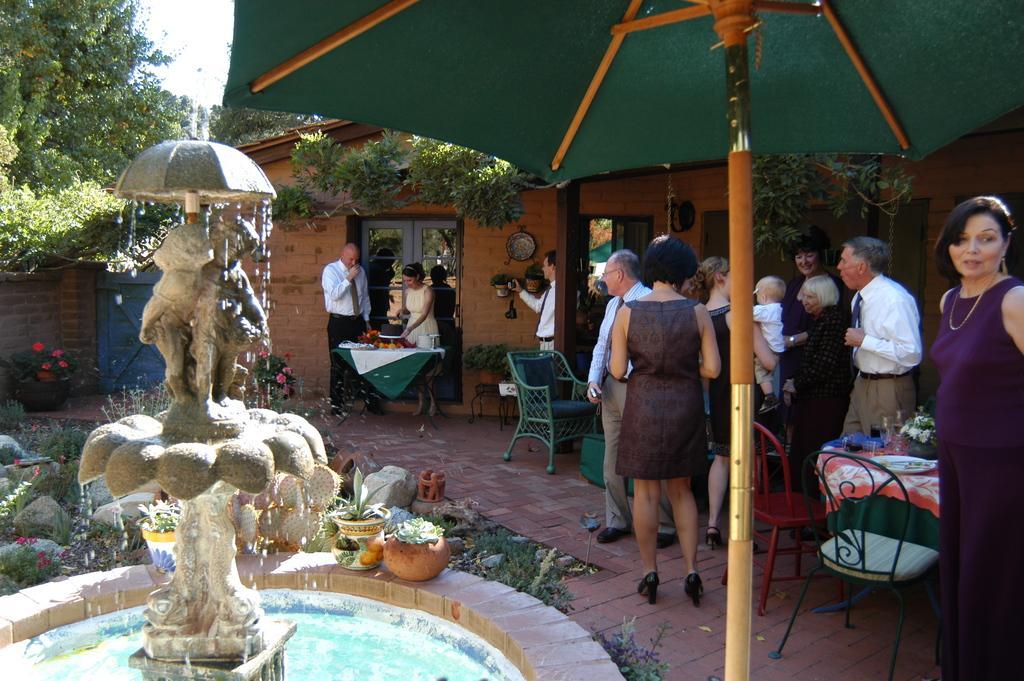Please provide a concise description of this image. This is a picture taken in the outdoors. It is sunny. There are group of people standing on the floor. In front of the woman there is a fountain with sculpture, water and flower pots and stones and umbrella. Behind the people there is a house, trees and sky. 